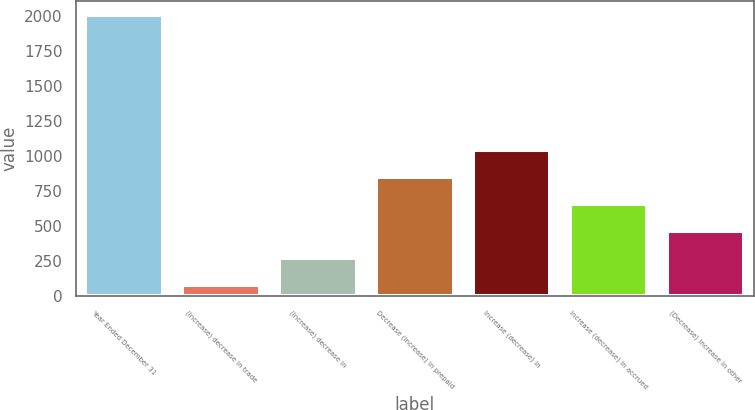Convert chart to OTSL. <chart><loc_0><loc_0><loc_500><loc_500><bar_chart><fcel>Year Ended December 31<fcel>(Increase) decrease in trade<fcel>(Increase) decrease in<fcel>Decrease (increase) in prepaid<fcel>Increase (decrease) in<fcel>Increase (decrease) in accrued<fcel>(Decrease) increase in other<nl><fcel>2005<fcel>79<fcel>271.6<fcel>849.4<fcel>1042<fcel>656.8<fcel>464.2<nl></chart> 